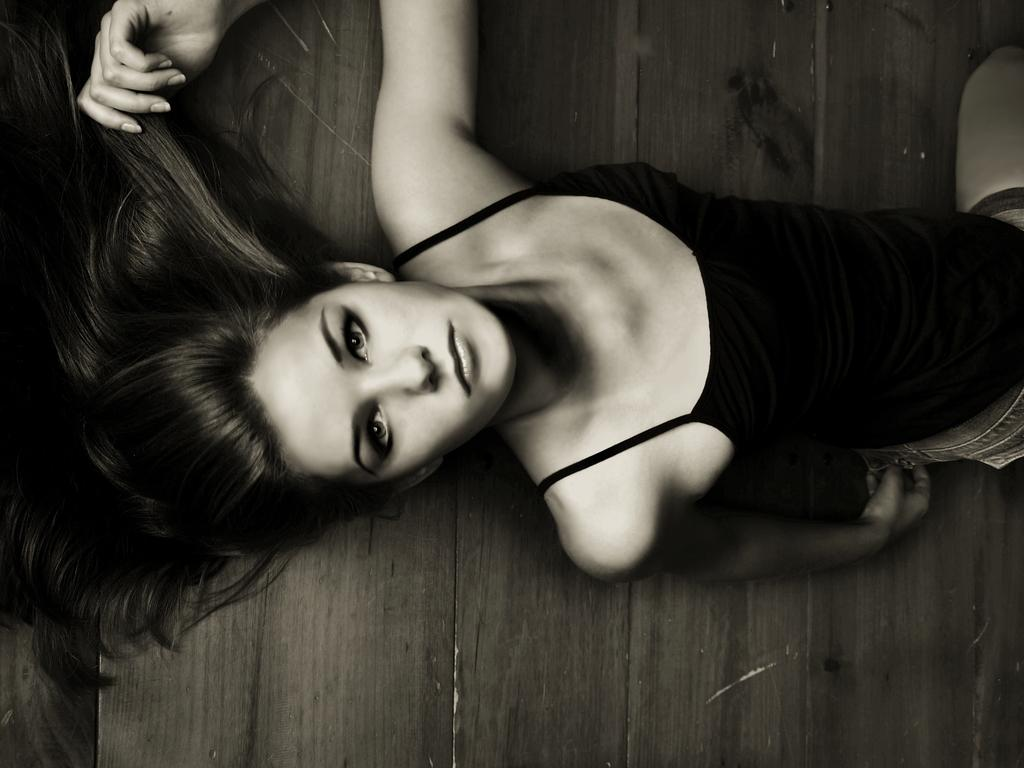What is the color scheme of the image? The image is black and white. Who is present in the image? There is a woman in the image. What is the woman wearing? The woman is wearing a black vest. What type of surface is the woman laying on? The woman is laying on the wooden floor. What type of division does the woman manage in the image? There is no indication in the image that the woman is a manager or that she manages any divisions. 